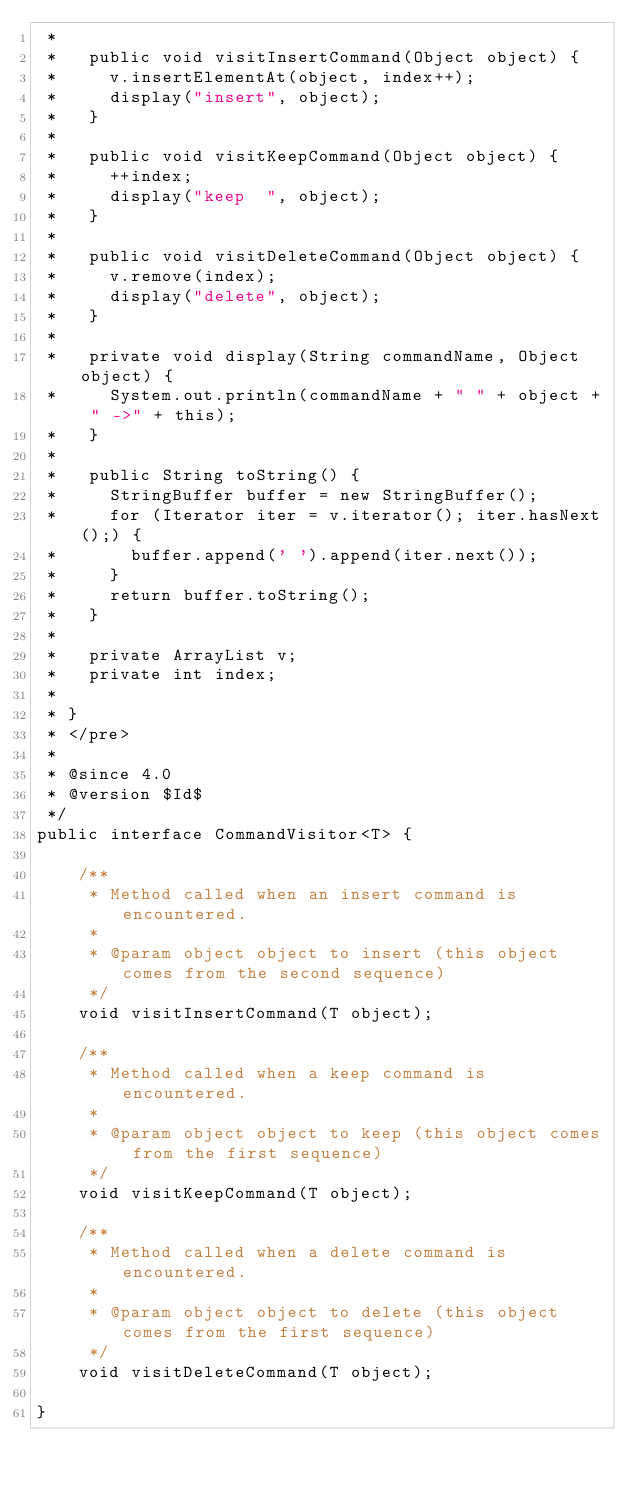Convert code to text. <code><loc_0><loc_0><loc_500><loc_500><_Java_> *
 *   public void visitInsertCommand(Object object) {
 *     v.insertElementAt(object, index++);
 *     display("insert", object);
 *   }
 *
 *   public void visitKeepCommand(Object object) {
 *     ++index;
 *     display("keep  ", object);
 *   }
 *
 *   public void visitDeleteCommand(Object object) {
 *     v.remove(index);
 *     display("delete", object);
 *   }
 *
 *   private void display(String commandName, Object object) {
 *     System.out.println(commandName + " " + object + " ->" + this);
 *   }
 *
 *   public String toString() {
 *     StringBuffer buffer = new StringBuffer();
 *     for (Iterator iter = v.iterator(); iter.hasNext();) {
 *       buffer.append(' ').append(iter.next());
 *     }
 *     return buffer.toString();
 *   }
 *
 *   private ArrayList v;
 *   private int index;
 *
 * }
 * </pre>
 *
 * @since 4.0
 * @version $Id$
 */
public interface CommandVisitor<T> {

    /**
     * Method called when an insert command is encountered.
     *
     * @param object object to insert (this object comes from the second sequence)
     */
    void visitInsertCommand(T object);

    /**
     * Method called when a keep command is encountered.
     *
     * @param object object to keep (this object comes from the first sequence)
     */
    void visitKeepCommand(T object);

    /**
     * Method called when a delete command is encountered.
     *
     * @param object object to delete (this object comes from the first sequence)
     */
    void visitDeleteCommand(T object);

}
</code> 